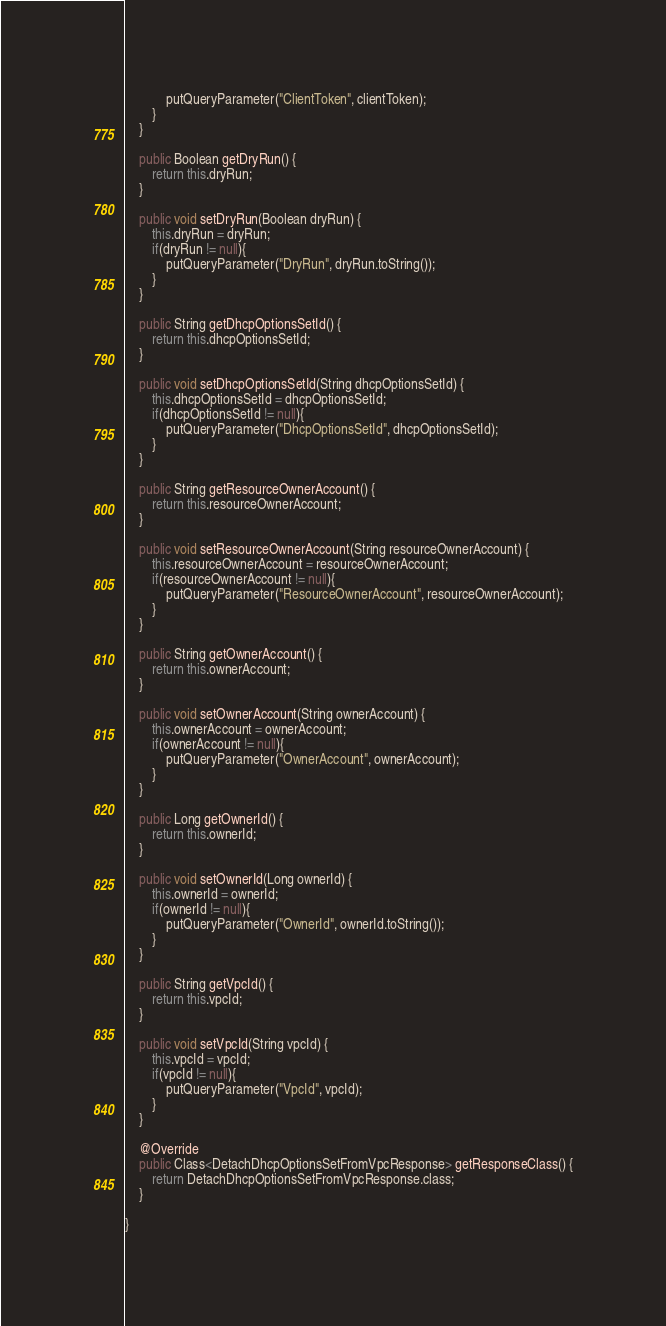<code> <loc_0><loc_0><loc_500><loc_500><_Java_>			putQueryParameter("ClientToken", clientToken);
		}
	}

	public Boolean getDryRun() {
		return this.dryRun;
	}

	public void setDryRun(Boolean dryRun) {
		this.dryRun = dryRun;
		if(dryRun != null){
			putQueryParameter("DryRun", dryRun.toString());
		}
	}

	public String getDhcpOptionsSetId() {
		return this.dhcpOptionsSetId;
	}

	public void setDhcpOptionsSetId(String dhcpOptionsSetId) {
		this.dhcpOptionsSetId = dhcpOptionsSetId;
		if(dhcpOptionsSetId != null){
			putQueryParameter("DhcpOptionsSetId", dhcpOptionsSetId);
		}
	}

	public String getResourceOwnerAccount() {
		return this.resourceOwnerAccount;
	}

	public void setResourceOwnerAccount(String resourceOwnerAccount) {
		this.resourceOwnerAccount = resourceOwnerAccount;
		if(resourceOwnerAccount != null){
			putQueryParameter("ResourceOwnerAccount", resourceOwnerAccount);
		}
	}

	public String getOwnerAccount() {
		return this.ownerAccount;
	}

	public void setOwnerAccount(String ownerAccount) {
		this.ownerAccount = ownerAccount;
		if(ownerAccount != null){
			putQueryParameter("OwnerAccount", ownerAccount);
		}
	}

	public Long getOwnerId() {
		return this.ownerId;
	}

	public void setOwnerId(Long ownerId) {
		this.ownerId = ownerId;
		if(ownerId != null){
			putQueryParameter("OwnerId", ownerId.toString());
		}
	}

	public String getVpcId() {
		return this.vpcId;
	}

	public void setVpcId(String vpcId) {
		this.vpcId = vpcId;
		if(vpcId != null){
			putQueryParameter("VpcId", vpcId);
		}
	}

	@Override
	public Class<DetachDhcpOptionsSetFromVpcResponse> getResponseClass() {
		return DetachDhcpOptionsSetFromVpcResponse.class;
	}

}
</code> 